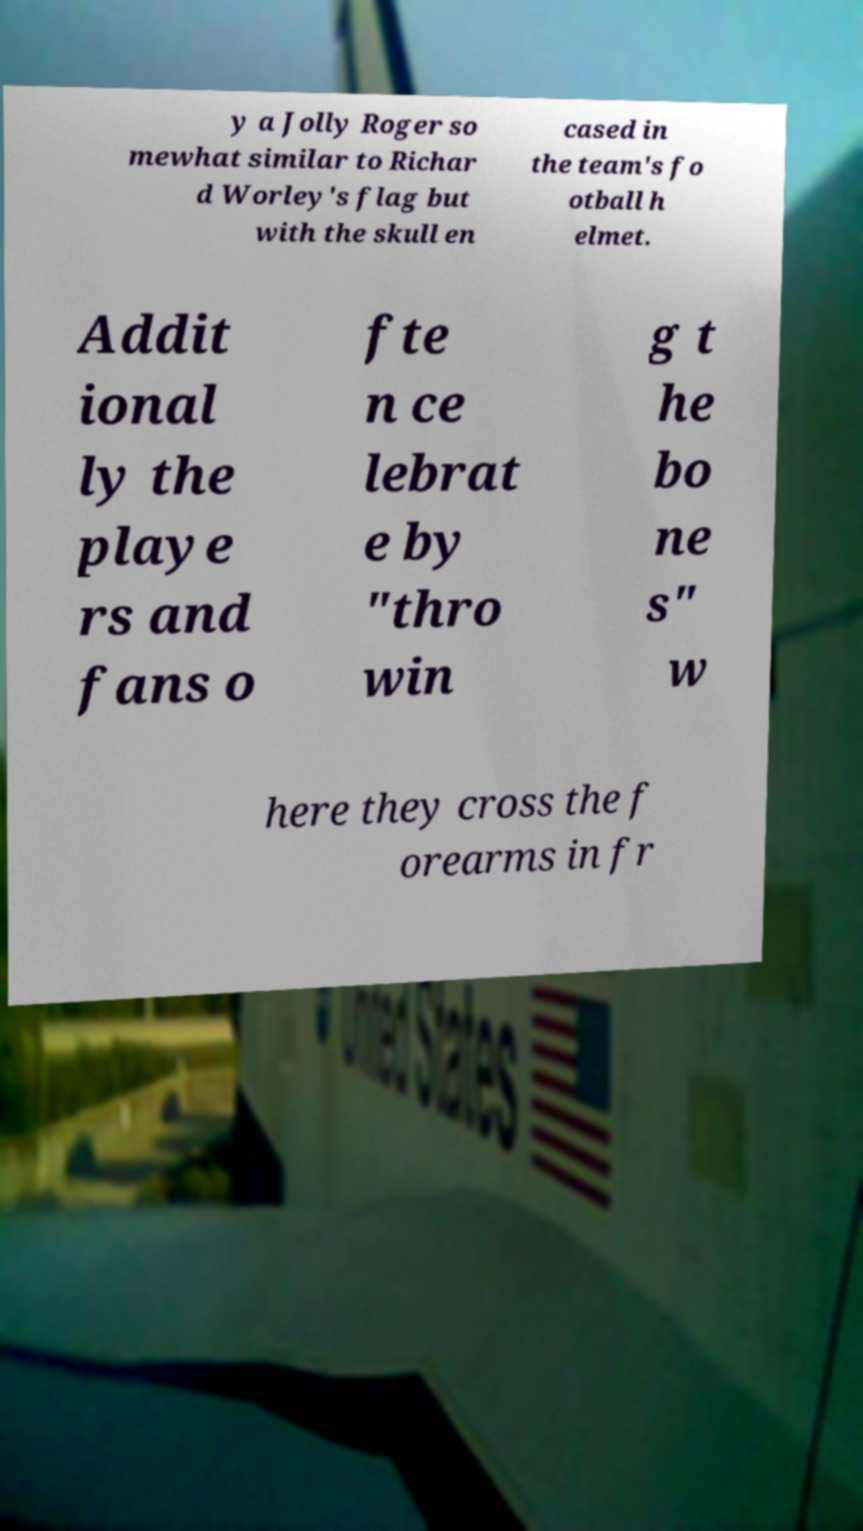Could you assist in decoding the text presented in this image and type it out clearly? y a Jolly Roger so mewhat similar to Richar d Worley's flag but with the skull en cased in the team's fo otball h elmet. Addit ional ly the playe rs and fans o fte n ce lebrat e by "thro win g t he bo ne s" w here they cross the f orearms in fr 